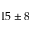Convert formula to latex. <formula><loc_0><loc_0><loc_500><loc_500>1 5 \pm 8</formula> 